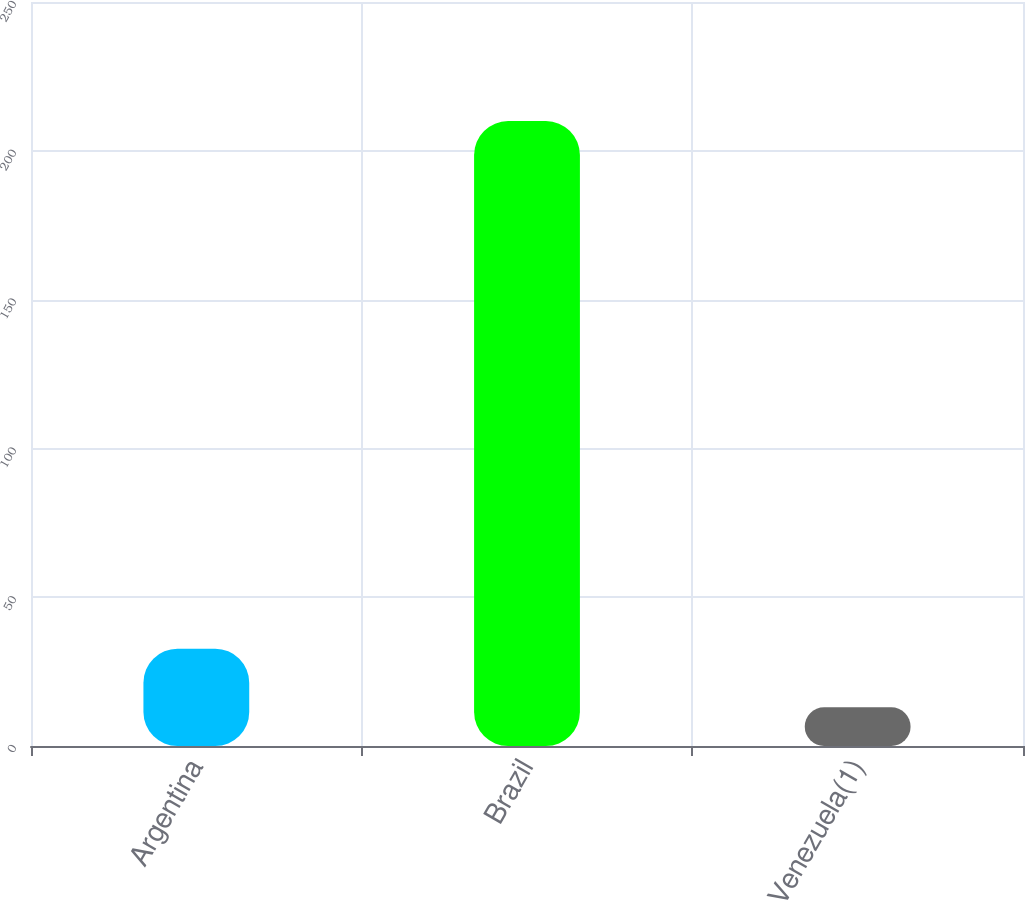Convert chart. <chart><loc_0><loc_0><loc_500><loc_500><bar_chart><fcel>Argentina<fcel>Brazil<fcel>Venezuela(1)<nl><fcel>32.7<fcel>210<fcel>13<nl></chart> 